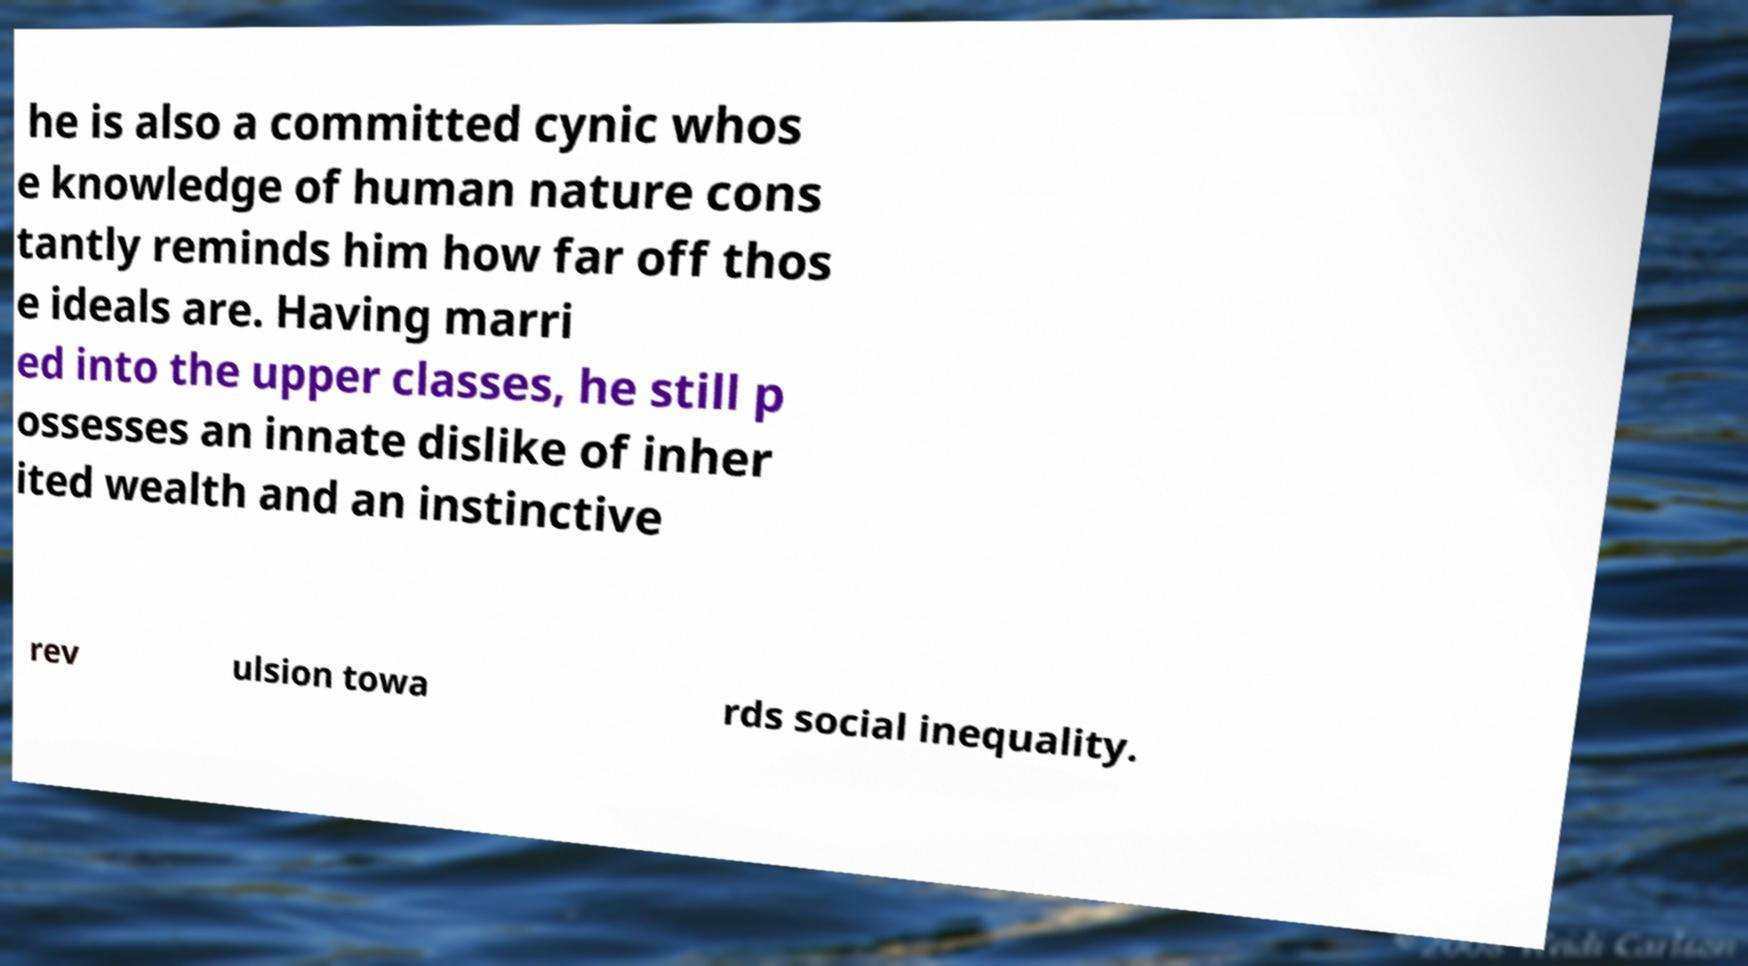Please read and relay the text visible in this image. What does it say? he is also a committed cynic whos e knowledge of human nature cons tantly reminds him how far off thos e ideals are. Having marri ed into the upper classes, he still p ossesses an innate dislike of inher ited wealth and an instinctive rev ulsion towa rds social inequality. 